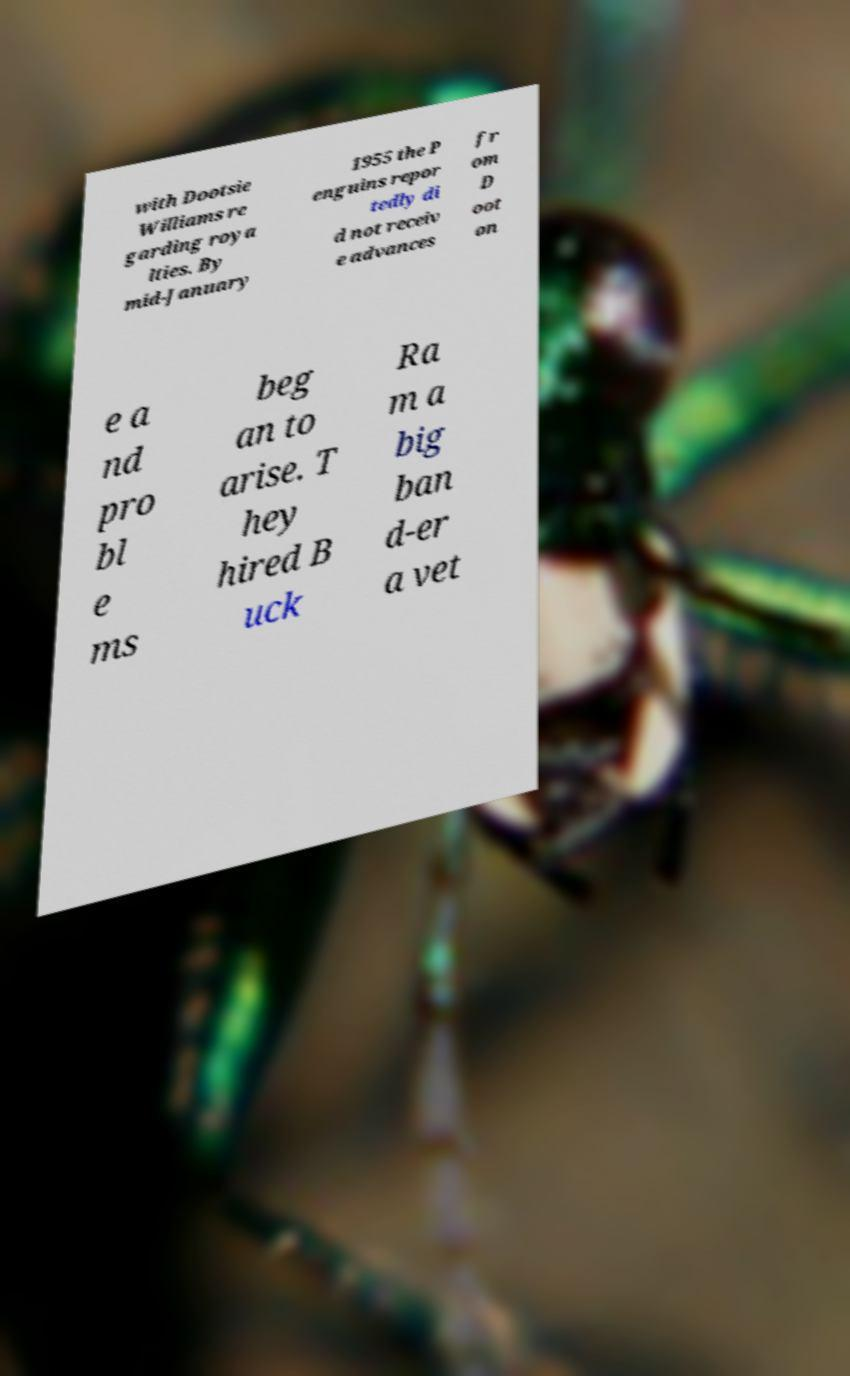There's text embedded in this image that I need extracted. Can you transcribe it verbatim? with Dootsie Williams re garding roya lties. By mid-January 1955 the P enguins repor tedly di d not receiv e advances fr om D oot on e a nd pro bl e ms beg an to arise. T hey hired B uck Ra m a big ban d-er a vet 